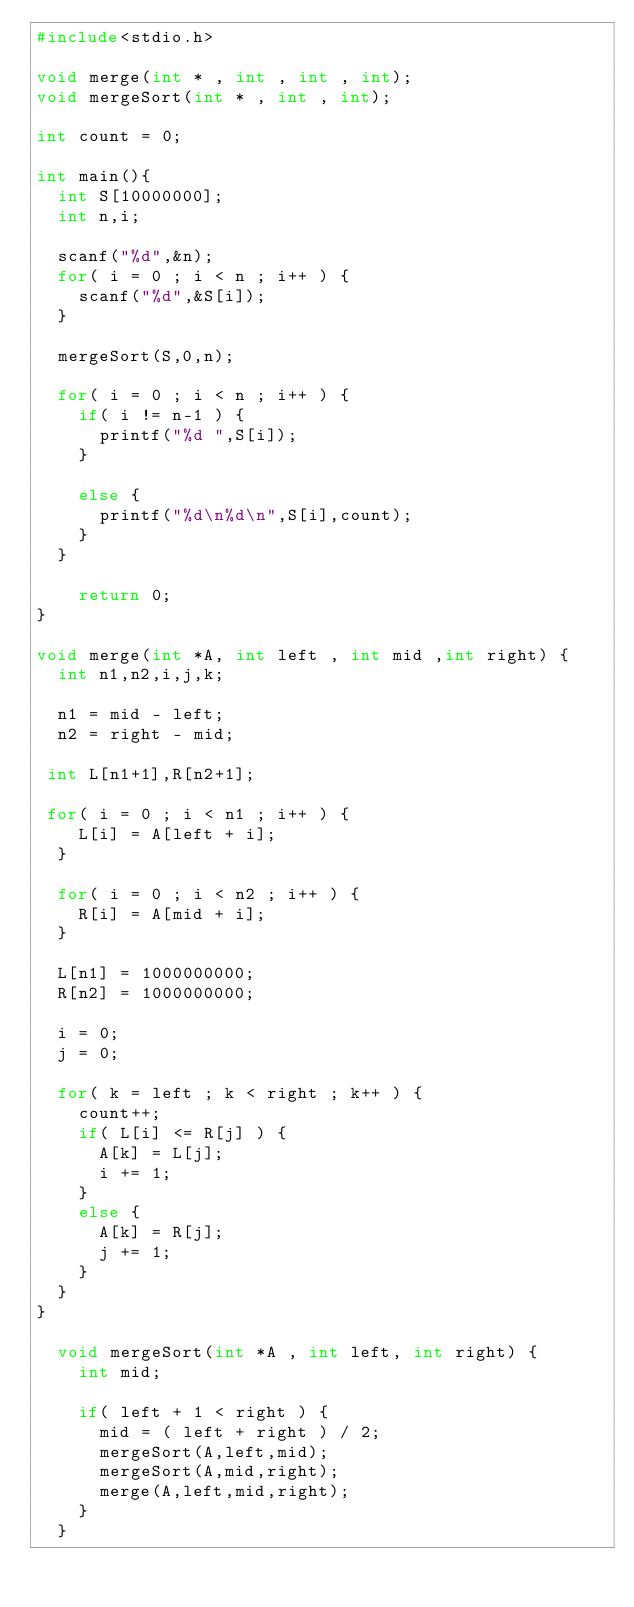Convert code to text. <code><loc_0><loc_0><loc_500><loc_500><_C_>#include<stdio.h>

void merge(int * , int , int , int);
void mergeSort(int * , int , int);

int count = 0;

int main(){
  int S[10000000];
  int n,i;

  scanf("%d",&n);
  for( i = 0 ; i < n ; i++ ) {
    scanf("%d",&S[i]);
  }

  mergeSort(S,0,n);

  for( i = 0 ; i < n ; i++ ) {
    if( i != n-1 ) {
      printf("%d ",S[i]);
    }

    else {
      printf("%d\n%d\n",S[i],count);
    }
  }
  
    return 0;
}

void merge(int *A, int left , int mid ,int right) {
  int n1,n2,i,j,k;
 
  n1 = mid - left;
  n2 = right - mid;
  
 int L[n1+1],R[n2+1];

 for( i = 0 ; i < n1 ; i++ ) {
    L[i] = A[left + i];
  }

  for( i = 0 ; i < n2 ; i++ ) {
    R[i] = A[mid + i];
  }

  L[n1] = 1000000000;
  R[n2] = 1000000000;

  i = 0;
  j = 0;

  for( k = left ; k < right ; k++ ) {
    count++;
    if( L[i] <= R[j] ) {
      A[k] = L[j];
      i += 1;
    }
    else {
      A[k] = R[j];
      j += 1;
    }
  }
}

  void mergeSort(int *A , int left, int right) {
    int mid;

    if( left + 1 < right ) {
      mid = ( left + right ) / 2;
      mergeSort(A,left,mid);
      mergeSort(A,mid,right);
      merge(A,left,mid,right);
    }
  }</code> 